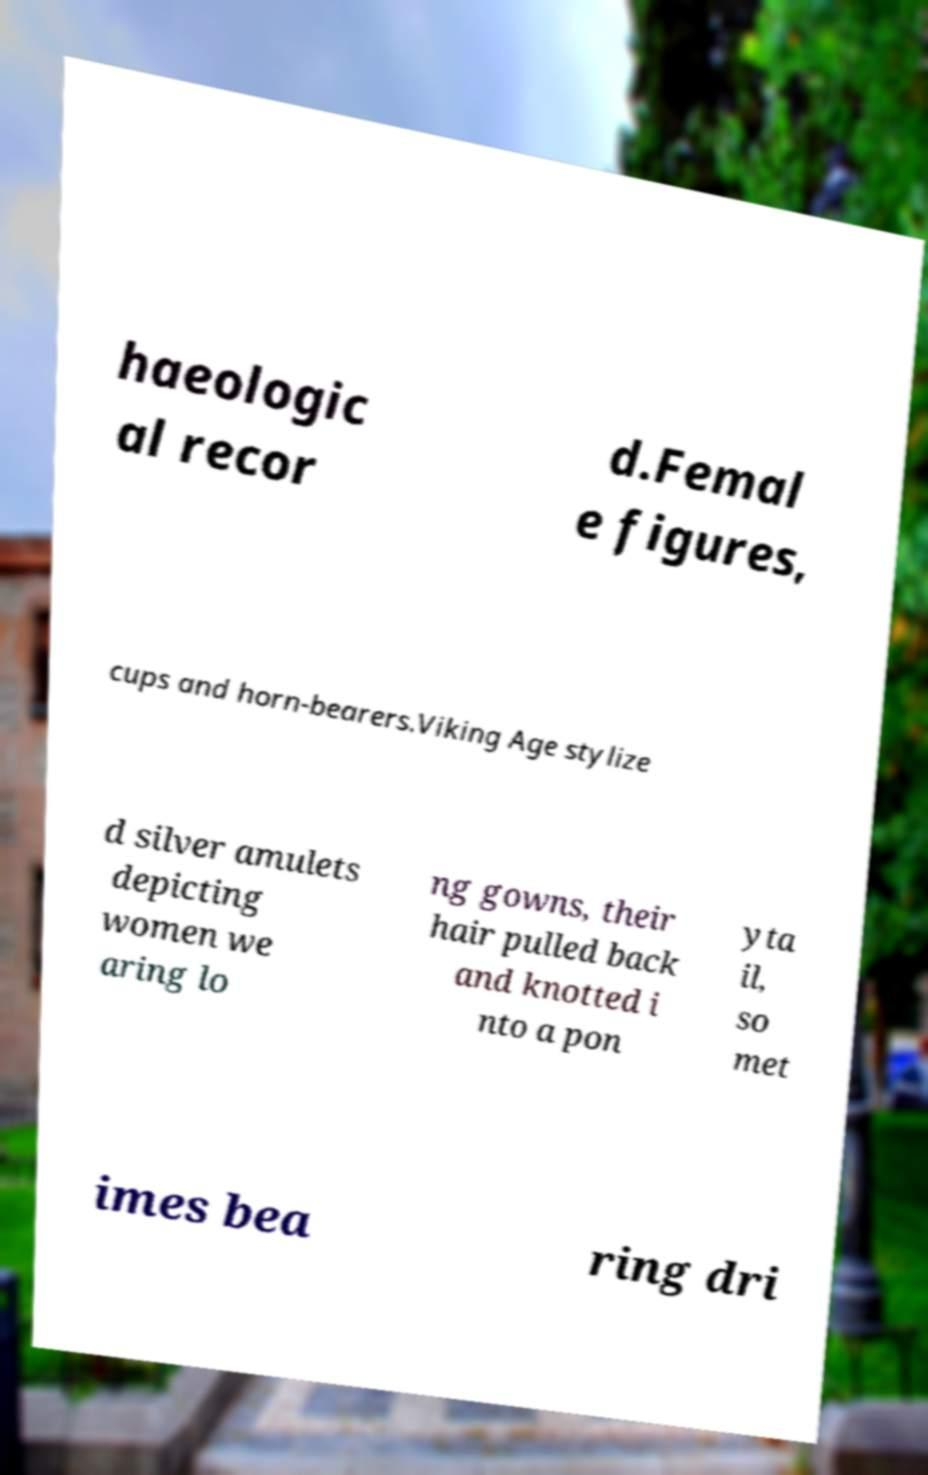There's text embedded in this image that I need extracted. Can you transcribe it verbatim? haeologic al recor d.Femal e figures, cups and horn-bearers.Viking Age stylize d silver amulets depicting women we aring lo ng gowns, their hair pulled back and knotted i nto a pon yta il, so met imes bea ring dri 